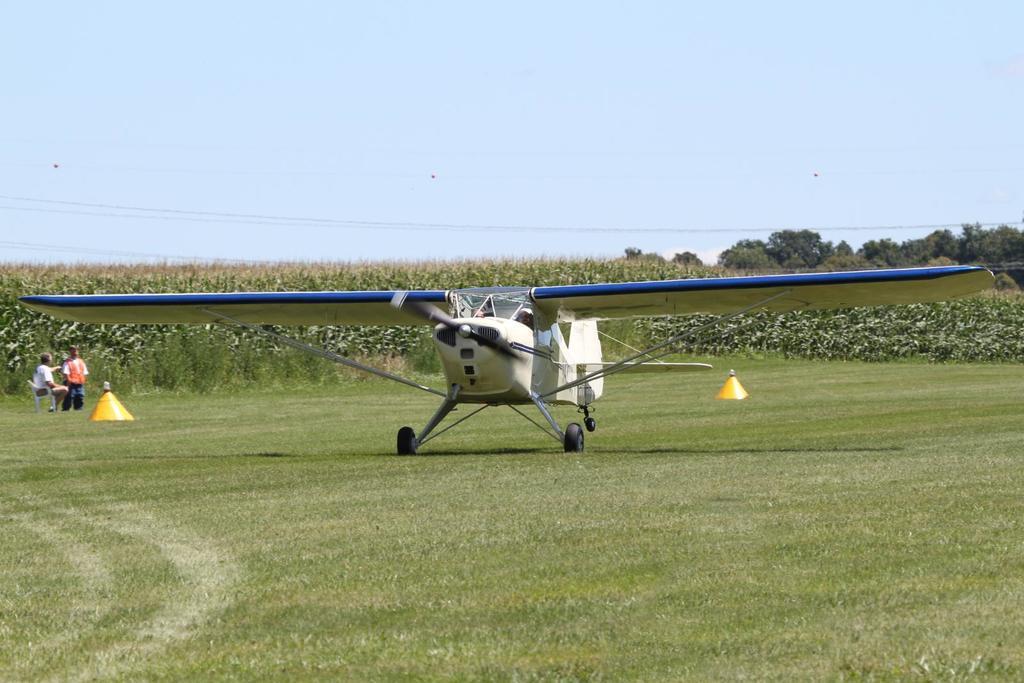In one or two sentences, can you explain what this image depicts? In this picture I can see the aircraft. I can see green grass. I can see trees in the background. I can see electric wires. I can see the people on the left side. I can see clouds in the sky. 